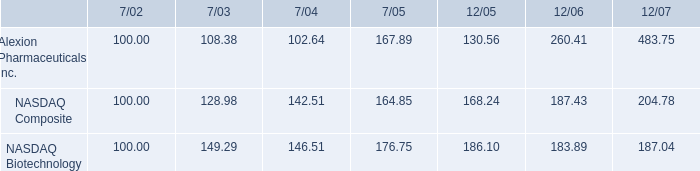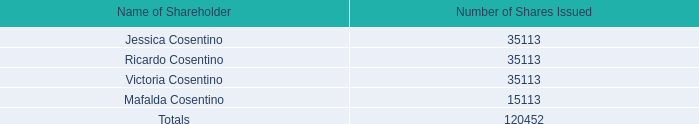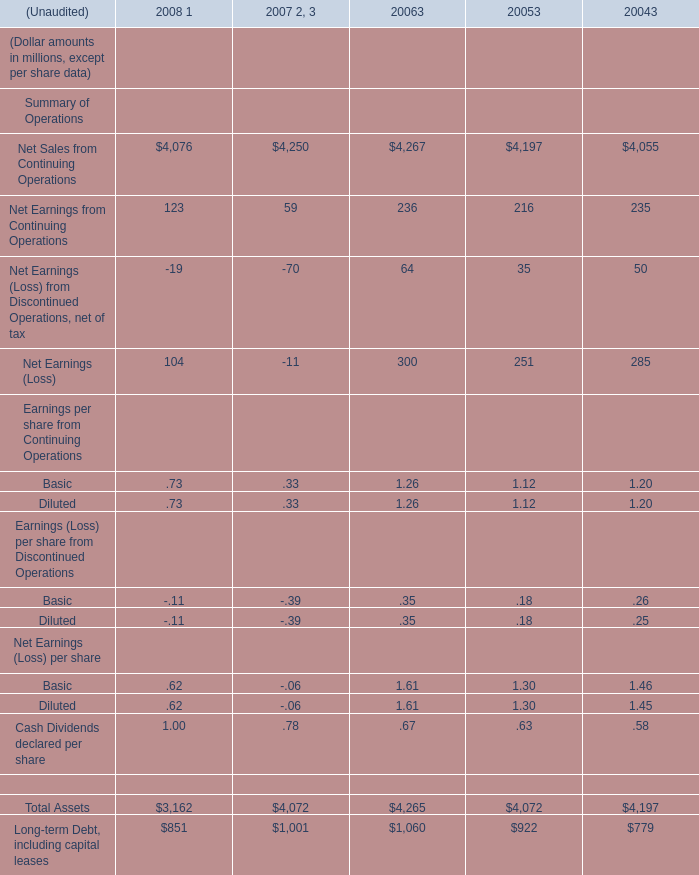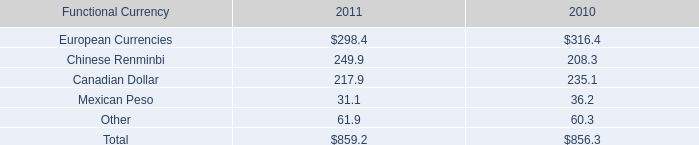What was the average value of the Net Sales from Continuing Operations in the years where Net Earnings (Loss) from Discontinued Operations, net of tax is positive? 
Computations: (((4267 + 4197) + 4055) / 3)
Answer: 4173.0. 